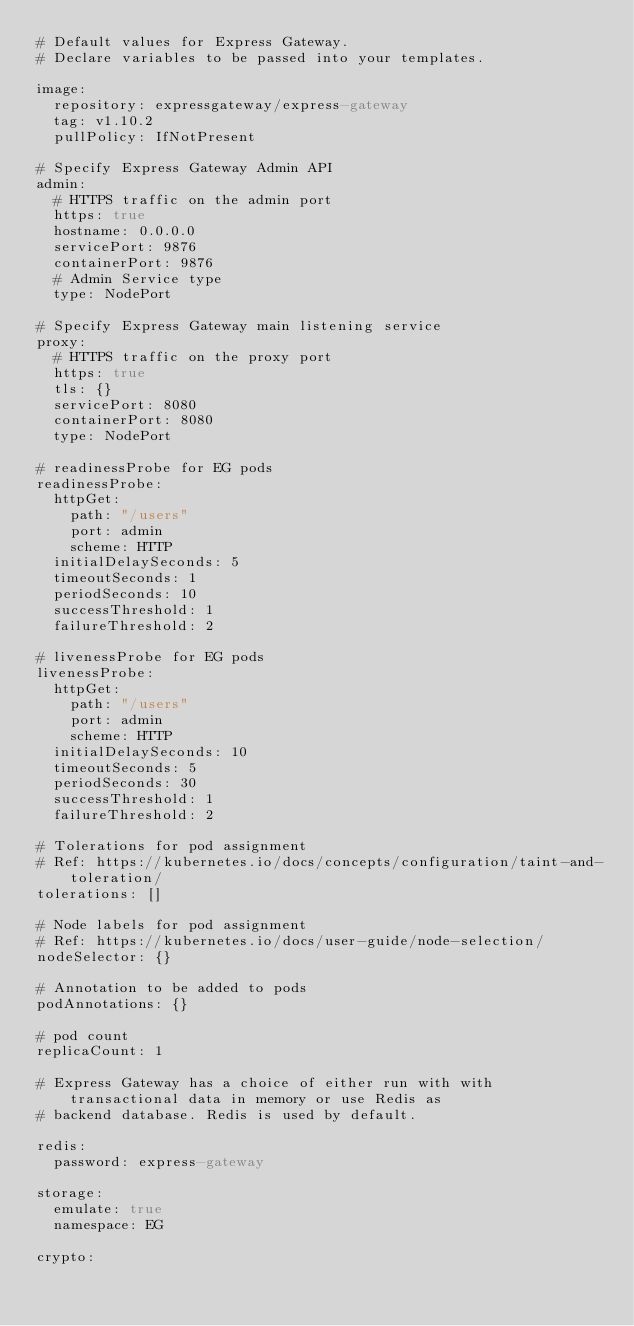<code> <loc_0><loc_0><loc_500><loc_500><_YAML_># Default values for Express Gateway.
# Declare variables to be passed into your templates.

image:
  repository: expressgateway/express-gateway
  tag: v1.10.2
  pullPolicy: IfNotPresent

# Specify Express Gateway Admin API
admin:
  # HTTPS traffic on the admin port
  https: true
  hostname: 0.0.0.0
  servicePort: 9876
  containerPort: 9876
  # Admin Service type
  type: NodePort

# Specify Express Gateway main listening service
proxy:
  # HTTPS traffic on the proxy port
  https: true
  tls: {}
  servicePort: 8080
  containerPort: 8080
  type: NodePort

# readinessProbe for EG pods
readinessProbe:
  httpGet:
    path: "/users"
    port: admin
    scheme: HTTP
  initialDelaySeconds: 5
  timeoutSeconds: 1
  periodSeconds: 10
  successThreshold: 1
  failureThreshold: 2

# livenessProbe for EG pods
livenessProbe:
  httpGet:
    path: "/users"
    port: admin
    scheme: HTTP
  initialDelaySeconds: 10
  timeoutSeconds: 5
  periodSeconds: 30
  successThreshold: 1
  failureThreshold: 2

# Tolerations for pod assignment
# Ref: https://kubernetes.io/docs/concepts/configuration/taint-and-toleration/
tolerations: []

# Node labels for pod assignment
# Ref: https://kubernetes.io/docs/user-guide/node-selection/
nodeSelector: {}

# Annotation to be added to pods
podAnnotations: {}

# pod count
replicaCount: 1

# Express Gateway has a choice of either run with with transactional data in memory or use Redis as
# backend database. Redis is used by default.

redis:
  password: express-gateway

storage:
  emulate: true
  namespace: EG

crypto:</code> 